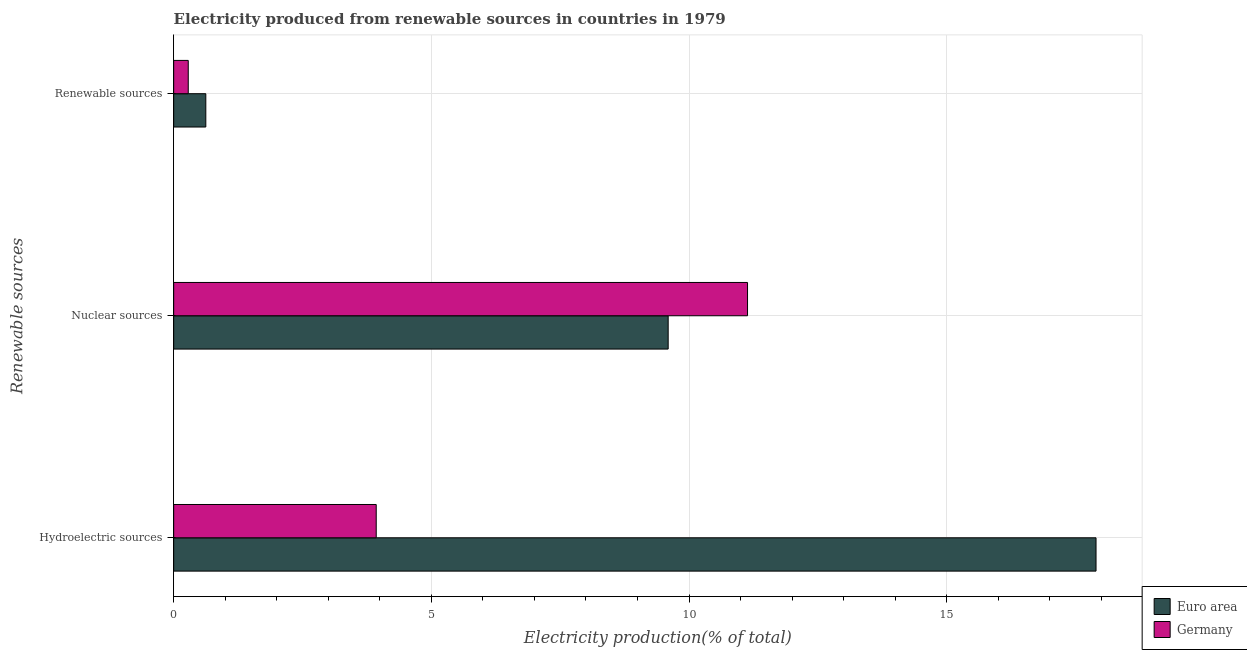How many groups of bars are there?
Offer a terse response. 3. Are the number of bars per tick equal to the number of legend labels?
Provide a succinct answer. Yes. Are the number of bars on each tick of the Y-axis equal?
Keep it short and to the point. Yes. What is the label of the 2nd group of bars from the top?
Ensure brevity in your answer.  Nuclear sources. What is the percentage of electricity produced by hydroelectric sources in Germany?
Your answer should be very brief. 3.93. Across all countries, what is the maximum percentage of electricity produced by hydroelectric sources?
Provide a short and direct response. 17.9. Across all countries, what is the minimum percentage of electricity produced by renewable sources?
Offer a very short reply. 0.28. In which country was the percentage of electricity produced by hydroelectric sources minimum?
Your answer should be very brief. Germany. What is the total percentage of electricity produced by hydroelectric sources in the graph?
Give a very brief answer. 21.83. What is the difference between the percentage of electricity produced by hydroelectric sources in Euro area and that in Germany?
Your answer should be compact. 13.97. What is the difference between the percentage of electricity produced by nuclear sources in Germany and the percentage of electricity produced by hydroelectric sources in Euro area?
Keep it short and to the point. -6.76. What is the average percentage of electricity produced by hydroelectric sources per country?
Make the answer very short. 10.91. What is the difference between the percentage of electricity produced by renewable sources and percentage of electricity produced by hydroelectric sources in Euro area?
Give a very brief answer. -17.27. In how many countries, is the percentage of electricity produced by renewable sources greater than 1 %?
Offer a terse response. 0. What is the ratio of the percentage of electricity produced by renewable sources in Germany to that in Euro area?
Keep it short and to the point. 0.45. What is the difference between the highest and the second highest percentage of electricity produced by renewable sources?
Ensure brevity in your answer.  0.34. What is the difference between the highest and the lowest percentage of electricity produced by hydroelectric sources?
Offer a very short reply. 13.97. What does the 2nd bar from the bottom in Hydroelectric sources represents?
Your answer should be compact. Germany. How many bars are there?
Provide a succinct answer. 6. Are all the bars in the graph horizontal?
Your answer should be very brief. Yes. How many countries are there in the graph?
Your answer should be very brief. 2. What is the difference between two consecutive major ticks on the X-axis?
Provide a succinct answer. 5. Where does the legend appear in the graph?
Your response must be concise. Bottom right. How many legend labels are there?
Make the answer very short. 2. What is the title of the graph?
Provide a short and direct response. Electricity produced from renewable sources in countries in 1979. What is the label or title of the X-axis?
Make the answer very short. Electricity production(% of total). What is the label or title of the Y-axis?
Keep it short and to the point. Renewable sources. What is the Electricity production(% of total) of Euro area in Hydroelectric sources?
Provide a succinct answer. 17.9. What is the Electricity production(% of total) of Germany in Hydroelectric sources?
Your response must be concise. 3.93. What is the Electricity production(% of total) in Euro area in Nuclear sources?
Your response must be concise. 9.6. What is the Electricity production(% of total) in Germany in Nuclear sources?
Provide a short and direct response. 11.13. What is the Electricity production(% of total) in Euro area in Renewable sources?
Ensure brevity in your answer.  0.62. What is the Electricity production(% of total) of Germany in Renewable sources?
Give a very brief answer. 0.28. Across all Renewable sources, what is the maximum Electricity production(% of total) in Euro area?
Make the answer very short. 17.9. Across all Renewable sources, what is the maximum Electricity production(% of total) in Germany?
Your response must be concise. 11.13. Across all Renewable sources, what is the minimum Electricity production(% of total) in Euro area?
Provide a succinct answer. 0.62. Across all Renewable sources, what is the minimum Electricity production(% of total) in Germany?
Your answer should be very brief. 0.28. What is the total Electricity production(% of total) of Euro area in the graph?
Give a very brief answer. 28.12. What is the total Electricity production(% of total) of Germany in the graph?
Offer a very short reply. 15.35. What is the difference between the Electricity production(% of total) in Euro area in Hydroelectric sources and that in Nuclear sources?
Your answer should be very brief. 8.3. What is the difference between the Electricity production(% of total) in Germany in Hydroelectric sources and that in Nuclear sources?
Your answer should be compact. -7.2. What is the difference between the Electricity production(% of total) of Euro area in Hydroelectric sources and that in Renewable sources?
Provide a short and direct response. 17.27. What is the difference between the Electricity production(% of total) in Germany in Hydroelectric sources and that in Renewable sources?
Give a very brief answer. 3.65. What is the difference between the Electricity production(% of total) of Euro area in Nuclear sources and that in Renewable sources?
Keep it short and to the point. 8.97. What is the difference between the Electricity production(% of total) of Germany in Nuclear sources and that in Renewable sources?
Keep it short and to the point. 10.85. What is the difference between the Electricity production(% of total) in Euro area in Hydroelectric sources and the Electricity production(% of total) in Germany in Nuclear sources?
Your response must be concise. 6.76. What is the difference between the Electricity production(% of total) in Euro area in Hydroelectric sources and the Electricity production(% of total) in Germany in Renewable sources?
Provide a short and direct response. 17.61. What is the difference between the Electricity production(% of total) in Euro area in Nuclear sources and the Electricity production(% of total) in Germany in Renewable sources?
Your response must be concise. 9.31. What is the average Electricity production(% of total) of Euro area per Renewable sources?
Offer a very short reply. 9.37. What is the average Electricity production(% of total) in Germany per Renewable sources?
Keep it short and to the point. 5.12. What is the difference between the Electricity production(% of total) of Euro area and Electricity production(% of total) of Germany in Hydroelectric sources?
Your answer should be compact. 13.97. What is the difference between the Electricity production(% of total) in Euro area and Electricity production(% of total) in Germany in Nuclear sources?
Offer a terse response. -1.54. What is the difference between the Electricity production(% of total) of Euro area and Electricity production(% of total) of Germany in Renewable sources?
Your answer should be very brief. 0.34. What is the ratio of the Electricity production(% of total) of Euro area in Hydroelectric sources to that in Nuclear sources?
Provide a short and direct response. 1.87. What is the ratio of the Electricity production(% of total) in Germany in Hydroelectric sources to that in Nuclear sources?
Ensure brevity in your answer.  0.35. What is the ratio of the Electricity production(% of total) of Euro area in Hydroelectric sources to that in Renewable sources?
Give a very brief answer. 28.7. What is the ratio of the Electricity production(% of total) of Germany in Hydroelectric sources to that in Renewable sources?
Make the answer very short. 13.9. What is the ratio of the Electricity production(% of total) in Euro area in Nuclear sources to that in Renewable sources?
Make the answer very short. 15.39. What is the ratio of the Electricity production(% of total) of Germany in Nuclear sources to that in Renewable sources?
Offer a very short reply. 39.38. What is the difference between the highest and the second highest Electricity production(% of total) in Euro area?
Provide a short and direct response. 8.3. What is the difference between the highest and the second highest Electricity production(% of total) in Germany?
Offer a terse response. 7.2. What is the difference between the highest and the lowest Electricity production(% of total) in Euro area?
Provide a succinct answer. 17.27. What is the difference between the highest and the lowest Electricity production(% of total) in Germany?
Offer a terse response. 10.85. 